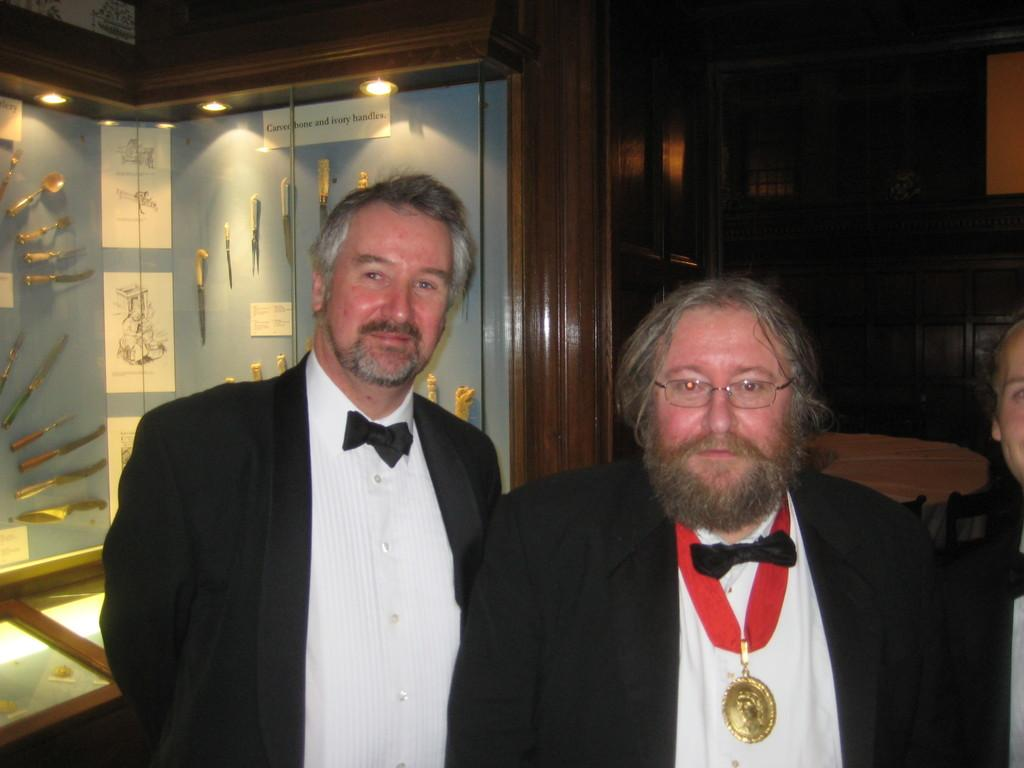How many people are in the image? There are three persons in the image. What can be seen in the background of the image? There is a rack visible in the image. What is attached to the rack on the wall? Knives are attached to the wall in the rack. What is the source of light in the image? There is lighting visible at the top of the image. What type of liquid is being discussed by the committee in the image? There is no committee or liquid present in the image. 